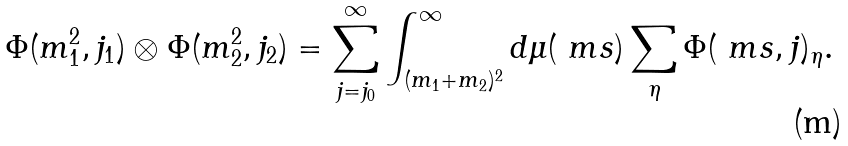Convert formula to latex. <formula><loc_0><loc_0><loc_500><loc_500>\Phi ( m _ { 1 } ^ { 2 } , j _ { 1 } ) \otimes \Phi ( m _ { 2 } ^ { 2 } , j _ { 2 } ) = \sum _ { j = j _ { 0 } } ^ { \infty } \int _ { ( m _ { 1 } + m _ { 2 } ) ^ { 2 } } ^ { \infty } d \mu ( \ m s ) \sum _ { \eta } \Phi ( \ m s , j ) _ { \eta } .</formula> 